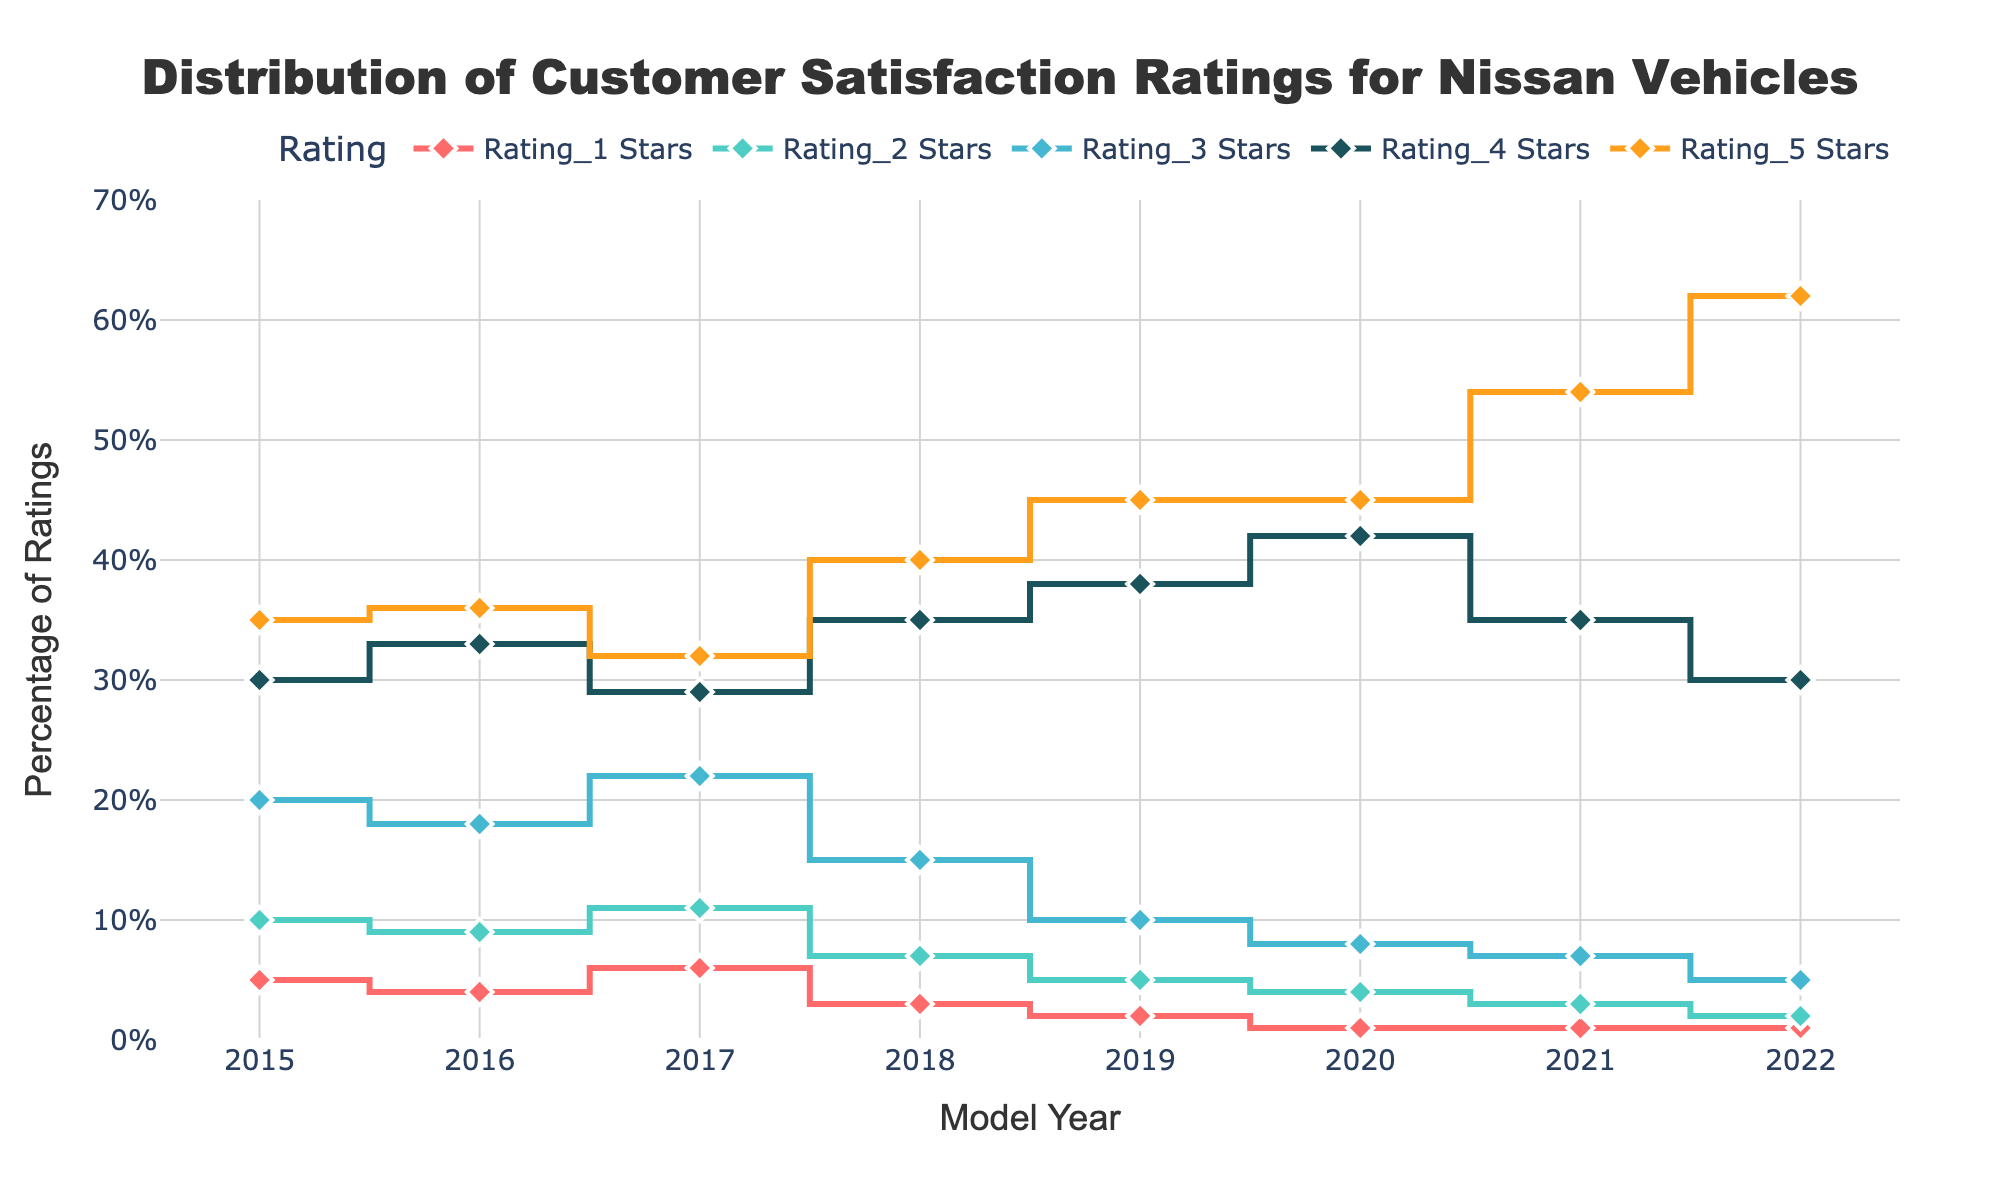What is the title of the plot? The title of the plot is displayed at the top center of the figure.
Answer: Distribution of Customer Satisfaction Ratings for Nissan Vehicles What is the range of the y-axis? The y-axis range can be found on the left vertical axis of the plot. It denotes the percentage of ratings and ranges from 0% to 70%.
Answer: 0% to 70% How many different rating levels are presented in the plot? There are five different rating levels presented, each represented by a different color and line pattern.
Answer: Five (Rating_1, Rating_2, Rating_3, Rating_4, Rating_5) Which rating level shows the highest percentage in 2022? By looking at the values for each rating level in 2022, we can see which one has the highest percentage. The Rating_5 line for 2022 is the highest at 62%.
Answer: Rating_5 For which model year is the percentage of Rating_1 the lowest? We examine the Rating_1 line and find the year with the lowest point. The lowest percentage of Rating_1 occurs in the year 2021 and 2022 both at 1%.
Answer: 2021 and 2022 What is the overall trend in the percentage of Rating_5 from 2015 to 2022? Observing the Rating_5 line from left to right shows the progression over the years. The percentage of Rating_5 has generally increased from 35% in 2015 to 62% in 2022.
Answer: Increasing How does the percentage of Rating_3 change from 2018 to 2020? By looking at the Rating_3 line, we compare the 2018, 2019, and 2020 data points. It decreases from 15% in 2018 to 10% in 2019, and further down to 8% in 2020.
Answer: Decreases Which model year has the highest combined percentage of 4-star and 5-star ratings? Adding the percentages of Rating_4 and Rating_5 for each year, the highest sum is calculated. The year with the highest combined percentage is 2022 with 30% (Rating_4) + 62% (Rating_5) = 92%.
Answer: 2022 What is the combined percentage of the lower ratings (Rating_1 and Rating_2) in 2019? Adding the percentages of Rating_1 and Rating_2 for the year 2019, we get 2% + 5% = 7%.
Answer: 7% Is there any year where Rating_5 constitutes more than 50% of the ratings? By examining the Rating_5 line, we check if it exceeds 50%. It does in 2021 (54%) and 2022 (62%).
Answer: 2021 and 2022 